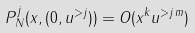<formula> <loc_0><loc_0><loc_500><loc_500>P _ { N } ^ { j } ( x , ( 0 , u ^ { > j } ) ) = O ( x ^ { k } \| u ^ { > j } \| ^ { m } )</formula> 